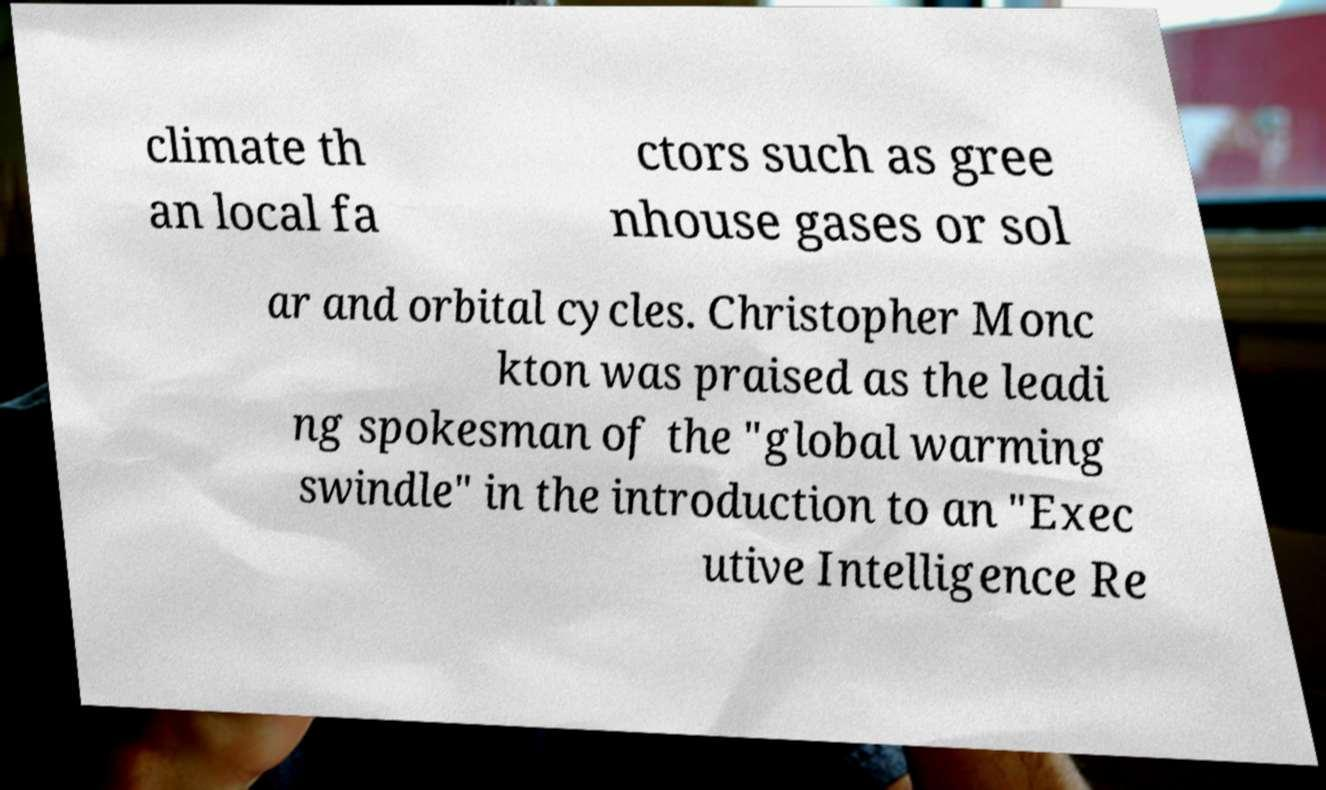For documentation purposes, I need the text within this image transcribed. Could you provide that? climate th an local fa ctors such as gree nhouse gases or sol ar and orbital cycles. Christopher Monc kton was praised as the leadi ng spokesman of the "global warming swindle" in the introduction to an "Exec utive Intelligence Re 